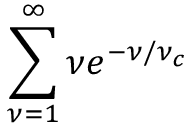Convert formula to latex. <formula><loc_0><loc_0><loc_500><loc_500>\sum _ { \nu = 1 } ^ { \infty } \nu e ^ { - \nu / \nu _ { c } }</formula> 